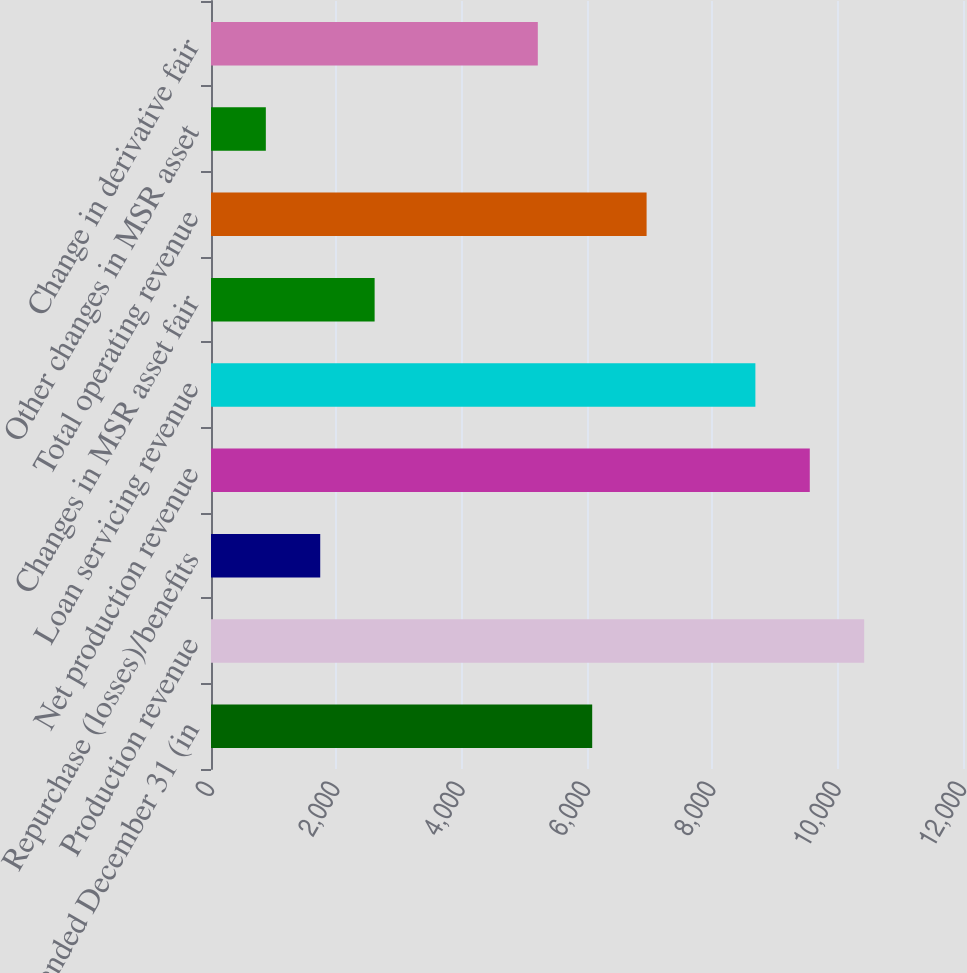<chart> <loc_0><loc_0><loc_500><loc_500><bar_chart><fcel>Year ended December 31 (in<fcel>Production revenue<fcel>Repurchase (losses)/benefits<fcel>Net production revenue<fcel>Loan servicing revenue<fcel>Changes in MSR asset fair<fcel>Total operating revenue<fcel>Other changes in MSR asset<fcel>Change in derivative fair<nl><fcel>6083<fcel>10423<fcel>1743<fcel>9555<fcel>8687<fcel>2611<fcel>6951<fcel>875<fcel>5215<nl></chart> 